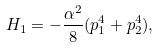Convert formula to latex. <formula><loc_0><loc_0><loc_500><loc_500>H _ { 1 } = - \frac { \alpha ^ { 2 } } { 8 } ( p _ { 1 } ^ { 4 } + p _ { 2 } ^ { 4 } ) ,</formula> 